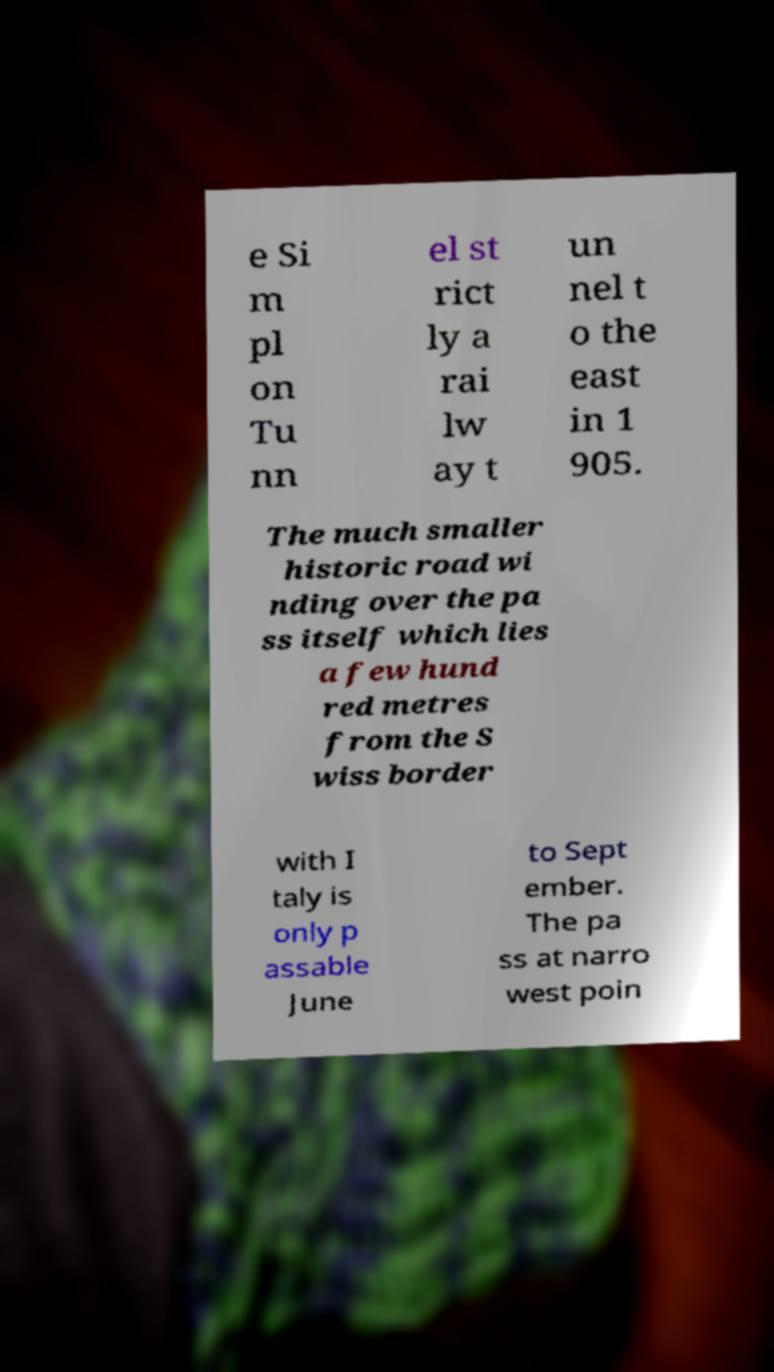There's text embedded in this image that I need extracted. Can you transcribe it verbatim? e Si m pl on Tu nn el st rict ly a rai lw ay t un nel t o the east in 1 905. The much smaller historic road wi nding over the pa ss itself which lies a few hund red metres from the S wiss border with I taly is only p assable June to Sept ember. The pa ss at narro west poin 